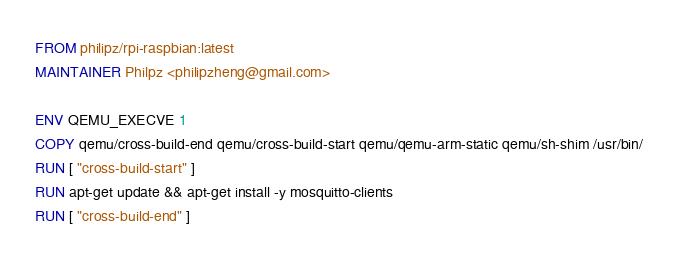Convert code to text. <code><loc_0><loc_0><loc_500><loc_500><_Dockerfile_>FROM philipz/rpi-raspbian:latest
MAINTAINER Philpz <philipzheng@gmail.com>

ENV QEMU_EXECVE 1
COPY qemu/cross-build-end qemu/cross-build-start qemu/qemu-arm-static qemu/sh-shim /usr/bin/
RUN [ "cross-build-start" ]
RUN apt-get update && apt-get install -y mosquitto-clients
RUN [ "cross-build-end" ]
</code> 